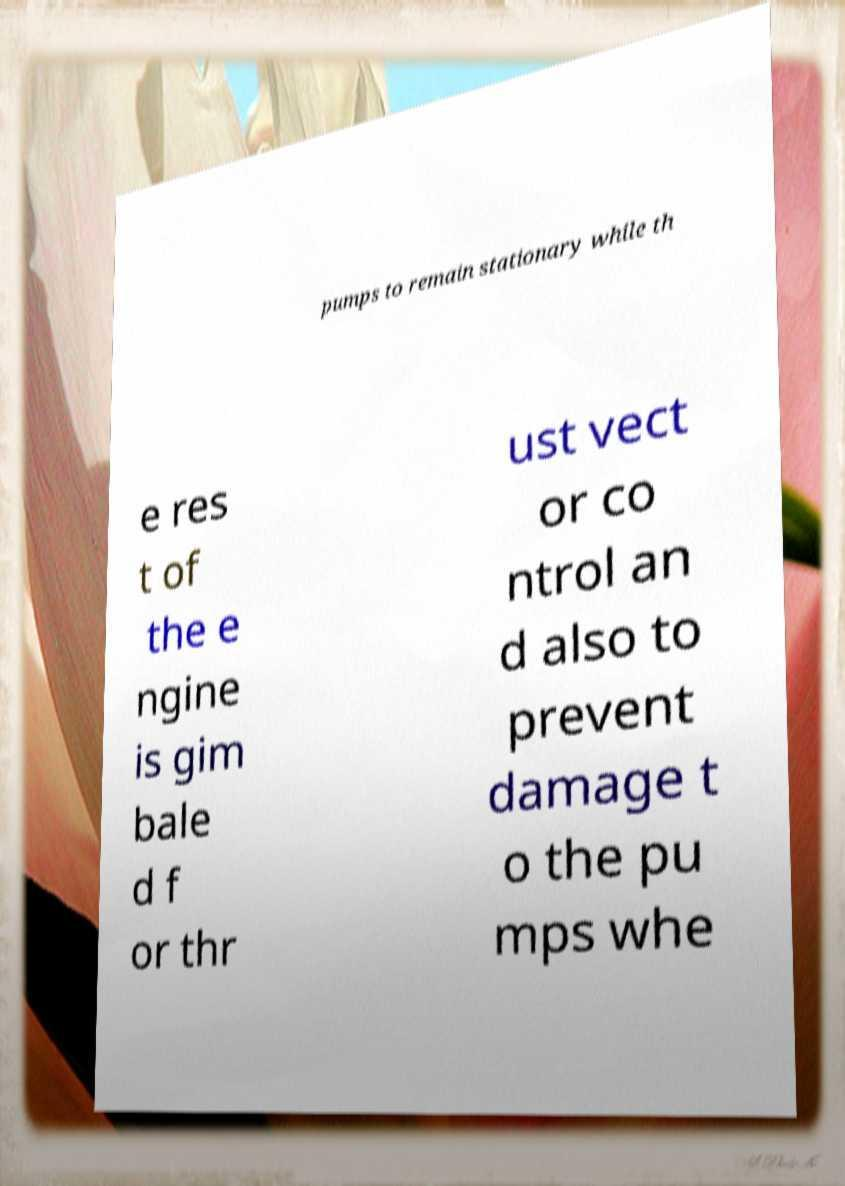Could you assist in decoding the text presented in this image and type it out clearly? pumps to remain stationary while th e res t of the e ngine is gim bale d f or thr ust vect or co ntrol an d also to prevent damage t o the pu mps whe 